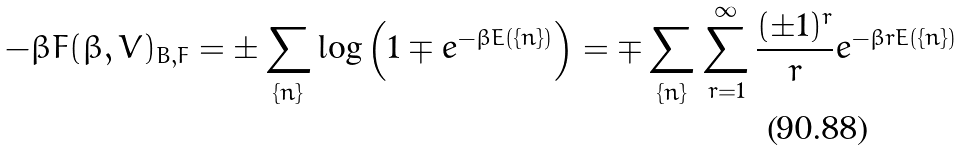<formula> <loc_0><loc_0><loc_500><loc_500>- \beta F ( \beta , V ) _ { B , F } = \pm \sum _ { \{ n \} } \log { \left ( 1 \mp e ^ { - \beta E ( \{ n \} ) } \right ) } = \mp \sum _ { \{ n \} } \sum ^ { \infty } _ { r = 1 } \frac { ( \pm 1 ) ^ { r } } { r } e ^ { - \beta r E ( \{ n \} ) }</formula> 